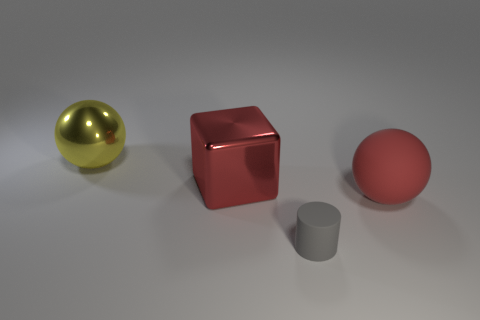Is there any other thing that is the same color as the metal block?
Offer a terse response. Yes. Is the shape of the matte object right of the gray object the same as  the yellow thing?
Provide a succinct answer. Yes. What is the material of the gray thing?
Ensure brevity in your answer.  Rubber. What is the shape of the large metal object in front of the big ball that is behind the big sphere that is to the right of the large yellow metallic thing?
Give a very brief answer. Cube. What number of other things are there of the same shape as the large yellow metal object?
Offer a very short reply. 1. There is a small thing; is it the same color as the big sphere that is to the right of the large metallic sphere?
Your answer should be very brief. No. How many rubber spheres are there?
Your answer should be very brief. 1. How many things are shiny spheres or big gray balls?
Keep it short and to the point. 1. What size is the metallic thing that is the same color as the rubber sphere?
Ensure brevity in your answer.  Large. Are there any red matte things in front of the red matte object?
Provide a short and direct response. No. 